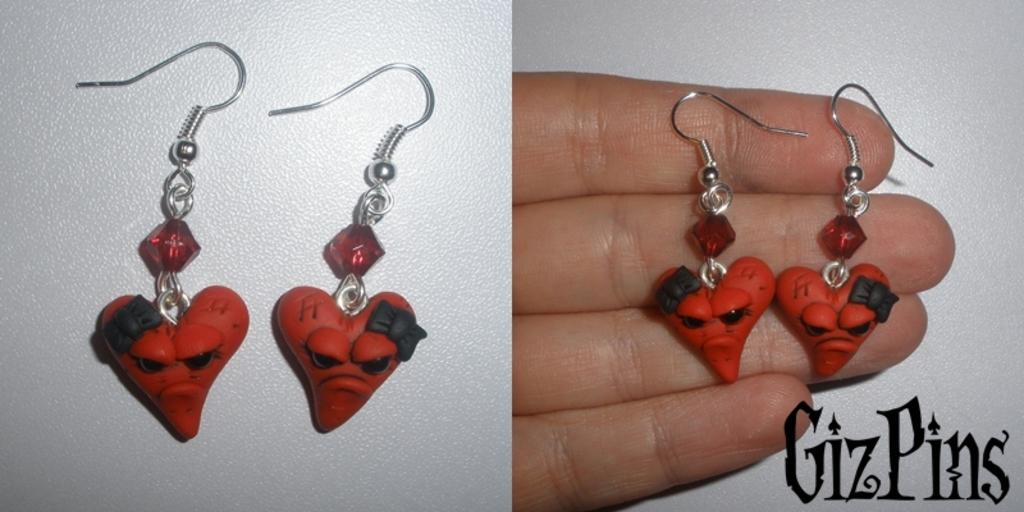What type of artwork is shown in the image? The image is a collage. What objects can be seen in the image related to jewelry? There are earrings placed on a surface and a person's hand holding earrings in the image. Is there any text present in the image? Yes, there is text in the image. How many oranges are being held by the person in the image? There are no oranges present in the image; it features earrings and text. What type of clothing is the man wearing in the image? There is no man present in the image, only earrings and text. 